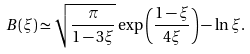Convert formula to latex. <formula><loc_0><loc_0><loc_500><loc_500>B ( \xi ) \simeq \sqrt { \frac { \pi } { 1 - 3 \xi } } \exp \left ( \frac { 1 - \xi } { 4 \xi } \right ) - \ln \xi .</formula> 